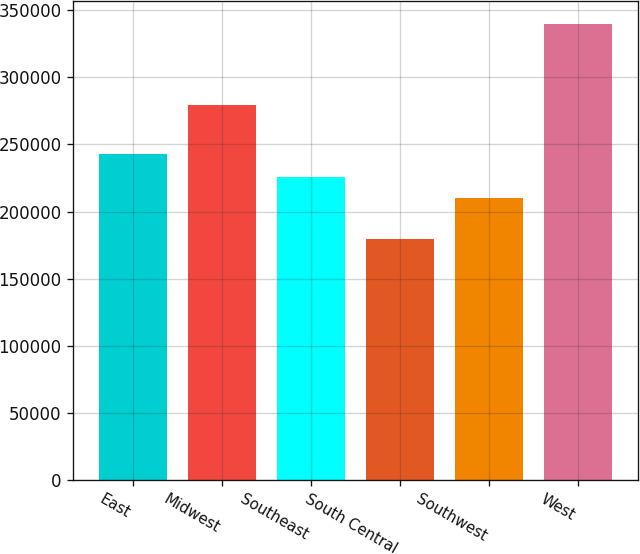Convert chart. <chart><loc_0><loc_0><loc_500><loc_500><bar_chart><fcel>East<fcel>Midwest<fcel>Southeast<fcel>South Central<fcel>Southwest<fcel>West<nl><fcel>242700<fcel>279300<fcel>226120<fcel>179800<fcel>210100<fcel>340000<nl></chart> 